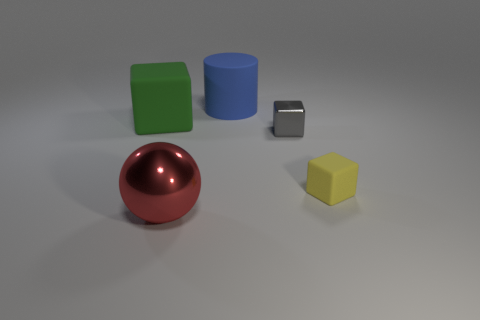Is the block that is on the left side of the big ball made of the same material as the tiny gray block?
Ensure brevity in your answer.  No. Are there the same number of red objects that are on the left side of the blue matte cylinder and small yellow rubber cubes to the right of the yellow matte block?
Make the answer very short. No. Is there any other thing that is the same size as the green cube?
Offer a terse response. Yes. What material is the other tiny thing that is the same shape as the small yellow object?
Provide a short and direct response. Metal. Are there any tiny yellow rubber objects that are behind the shiny object behind the yellow rubber object that is on the right side of the big blue rubber cylinder?
Provide a short and direct response. No. There is a rubber thing that is on the left side of the big sphere; is it the same shape as the blue matte thing behind the big block?
Offer a very short reply. No. Is the number of blue matte cylinders that are to the left of the gray block greater than the number of blue objects?
Your answer should be very brief. No. What number of things are gray metallic things or big blue blocks?
Provide a succinct answer. 1. What is the color of the big sphere?
Make the answer very short. Red. Are there any tiny gray shiny blocks in front of the big red ball?
Give a very brief answer. No. 